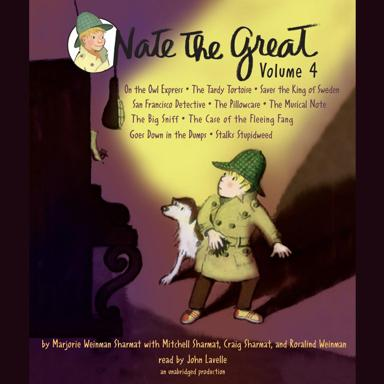What is the title of Volume 4 mentioned in the image?
 The title is "The Great Volume 4." What are some of the stories included in "The Great Volume 4"? Some of the stories included in this volume are "O the Owl Expre'", "The Tardy Tortoise Saves the King of Sweden," "San Francisco Detective," "The Pillowcare," "The Musical Note," "The Big Sniff," "The Case of the Fleeing Fang," and "Goes Down in the Dumps Stalks Stupidweed." Who are the authors of these stories? The authors of the stories are Marjorie Weinan Sharman, Mitchell Sharmat, and Rosalind Weinman. 